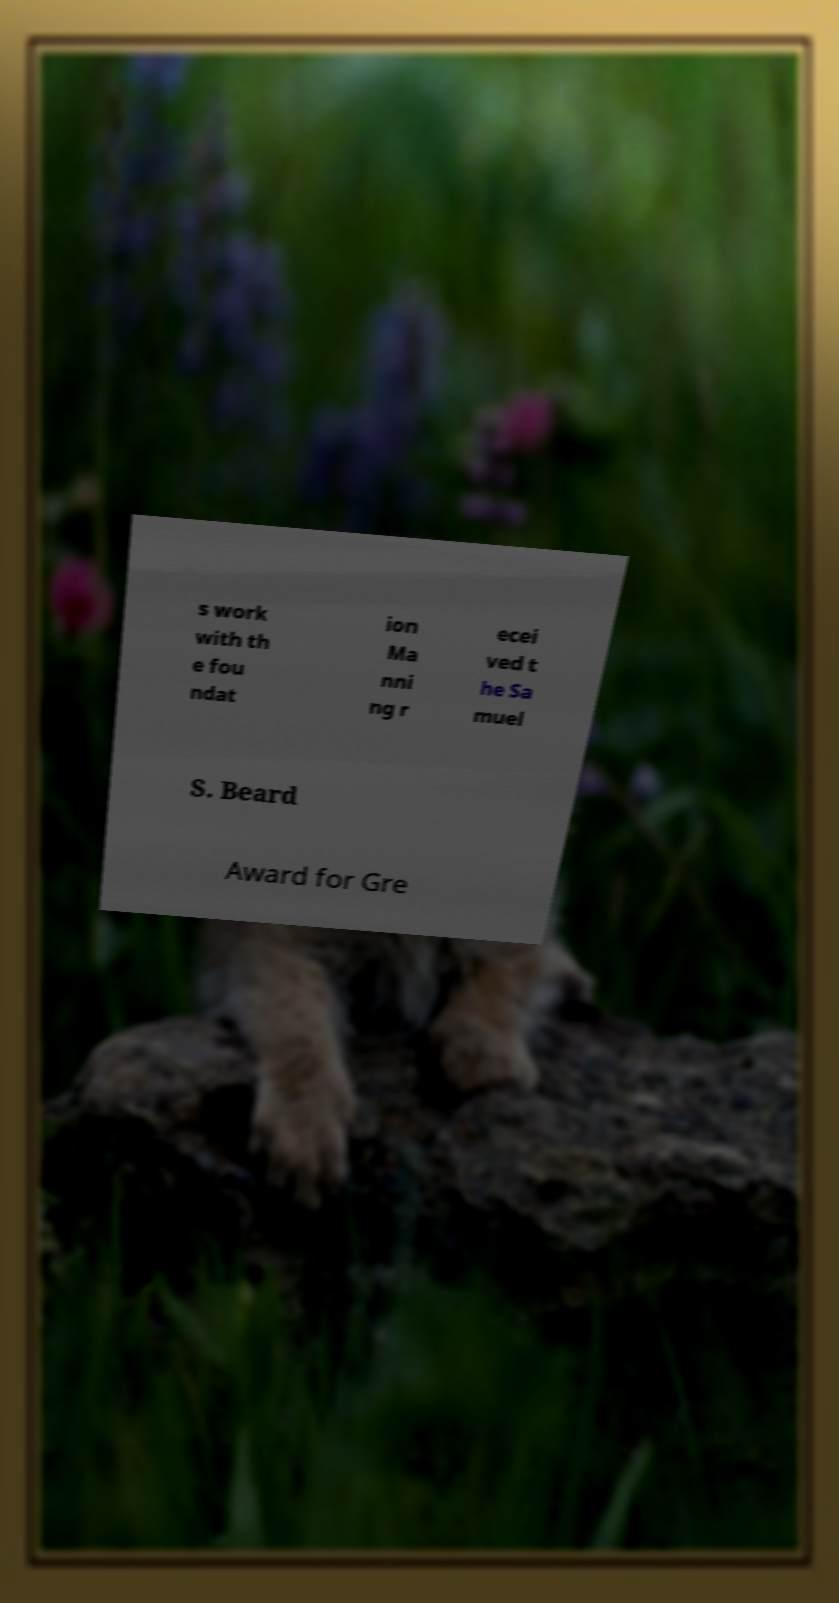Could you extract and type out the text from this image? s work with th e fou ndat ion Ma nni ng r ecei ved t he Sa muel S. Beard Award for Gre 